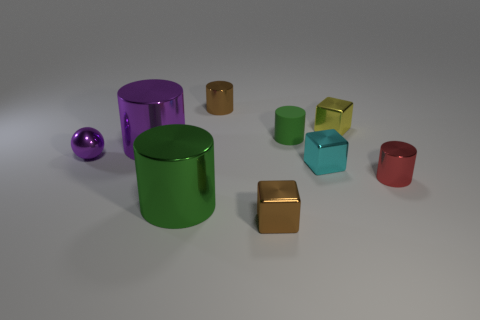Is there anything else that has the same material as the tiny green cylinder?
Ensure brevity in your answer.  No. What is the material of the purple sphere that is the same size as the green rubber thing?
Make the answer very short. Metal. Do the metallic cylinder in front of the red shiny object and the purple metal sphere have the same size?
Offer a very short reply. No. Is the shape of the green object that is behind the green metallic cylinder the same as  the red metal thing?
Offer a terse response. Yes. What number of objects are rubber cylinders or shiny cylinders that are in front of the yellow metal thing?
Give a very brief answer. 4. Is the number of large objects less than the number of gray spheres?
Your answer should be very brief. No. Are there more tiny yellow shiny blocks than metallic objects?
Provide a short and direct response. No. How many other things are there of the same material as the purple ball?
Make the answer very short. 7. What number of green cylinders are right of the tiny metal cube left of the green cylinder on the right side of the large green thing?
Offer a terse response. 1. How many metal objects are either big cyan things or brown objects?
Your answer should be compact. 2. 